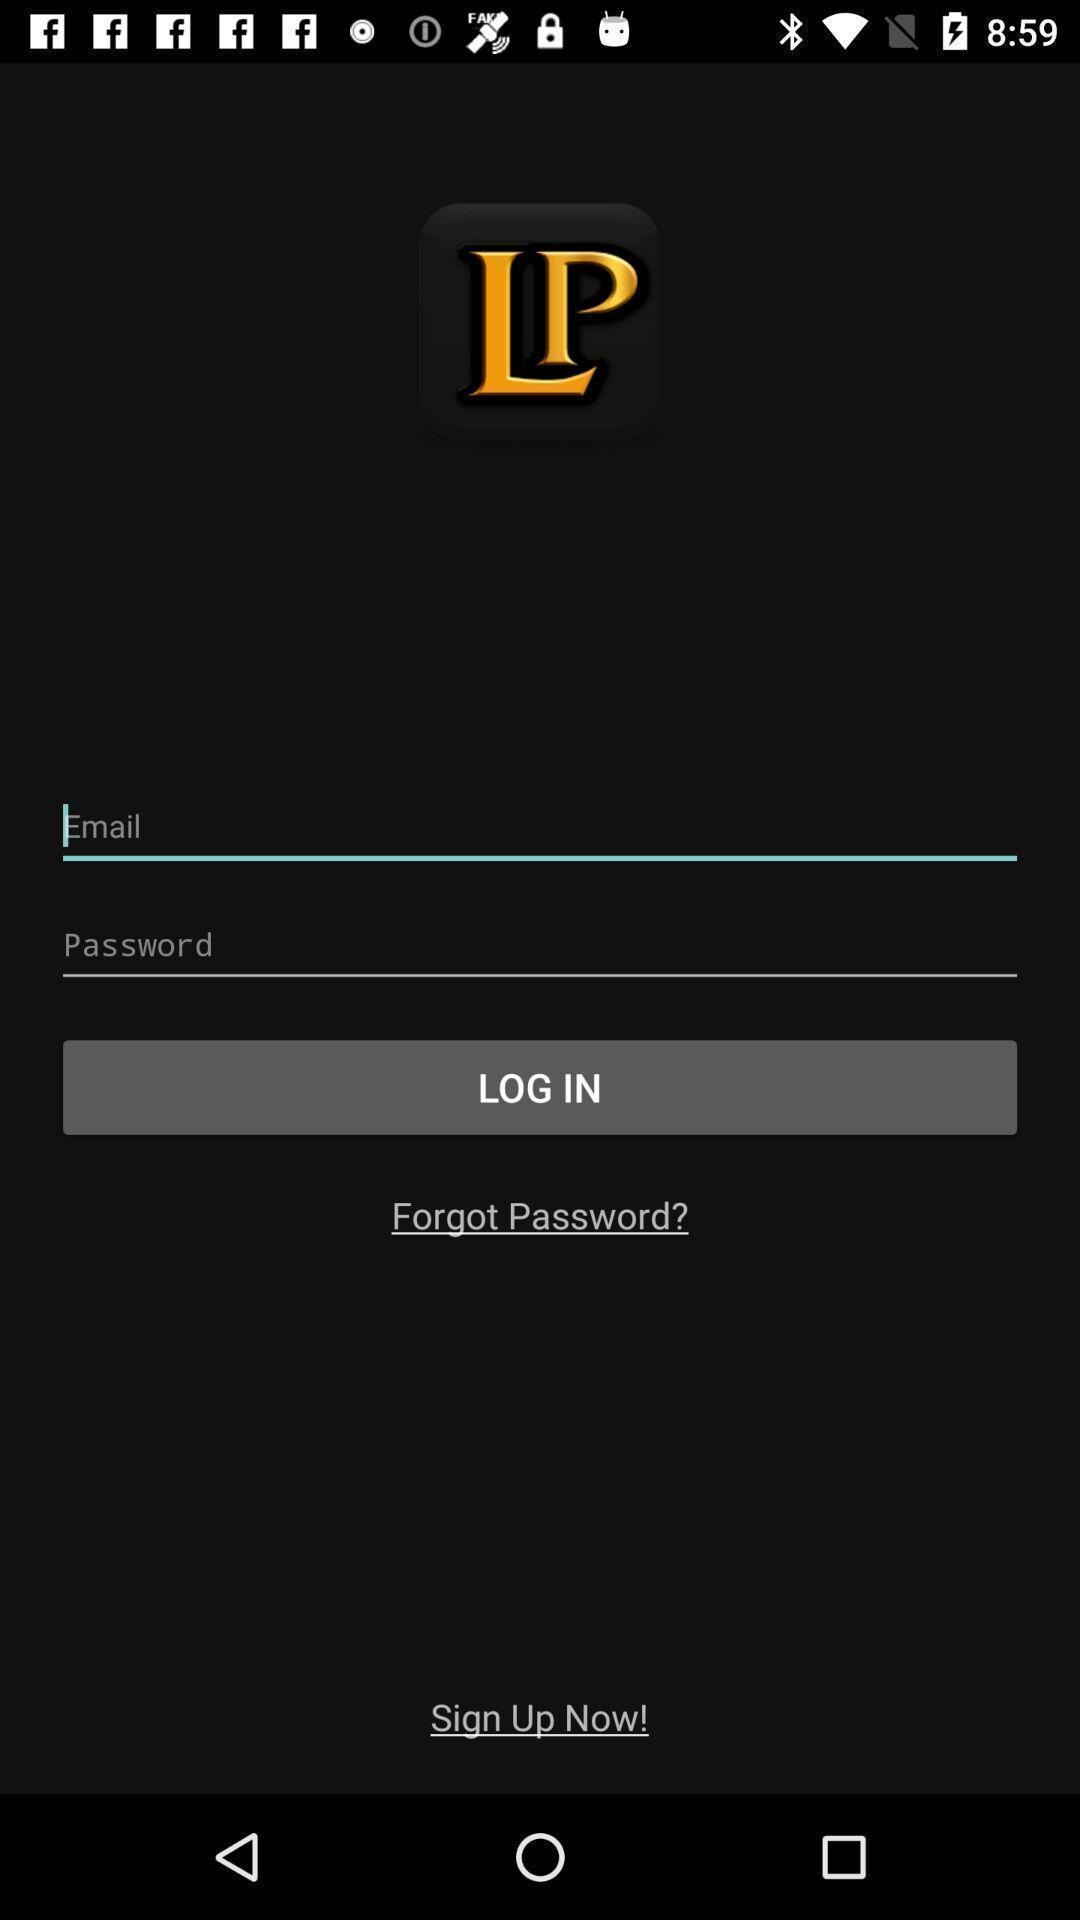What can you discern from this picture? Login page. 